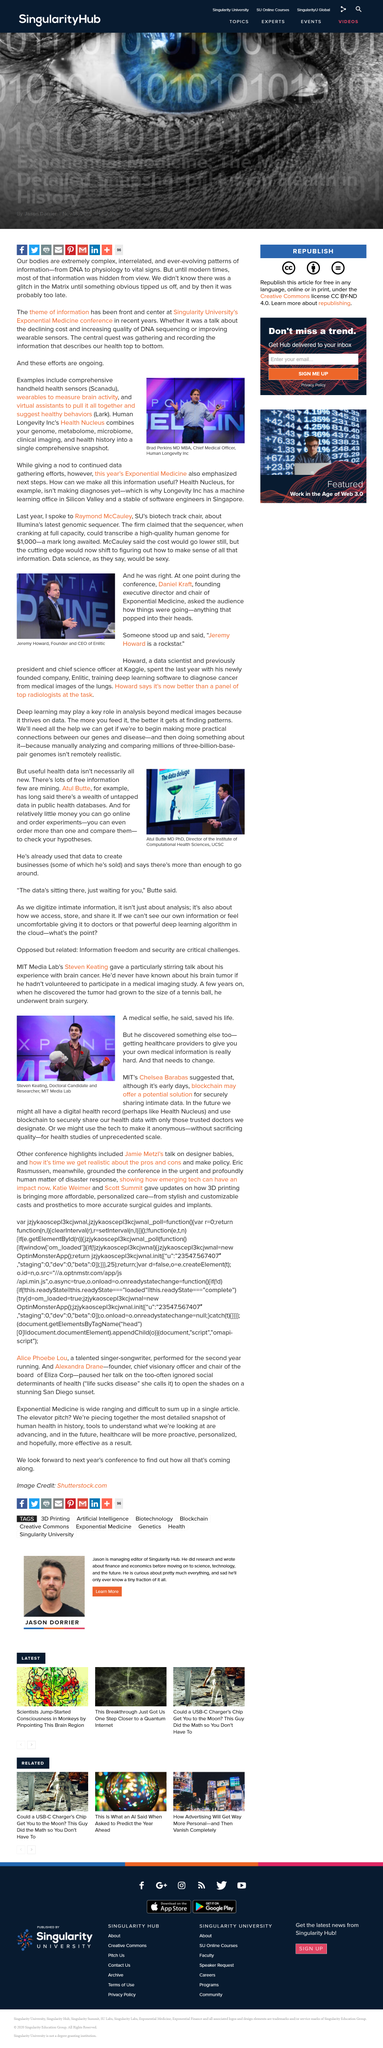Indicate a few pertinent items in this graphic. Jeremy Howard, the founder and CEO of Entlitic, is known for his exceptional leadership and entrepreneurial spirit in the technology industry. Yes, there is a wealth of untapped data in public health databases, as Atul Butte has repeatedly stated. Atul Butte has used the data to create businesses, innovate medical technologies, and improve healthcare outcomes. The above picture depicts Steven Keating. At a conference hosted by Singularity University, the theme of information was discussed. 